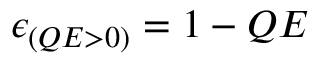Convert formula to latex. <formula><loc_0><loc_0><loc_500><loc_500>\epsilon _ { ( Q E > 0 ) } = 1 - Q E</formula> 